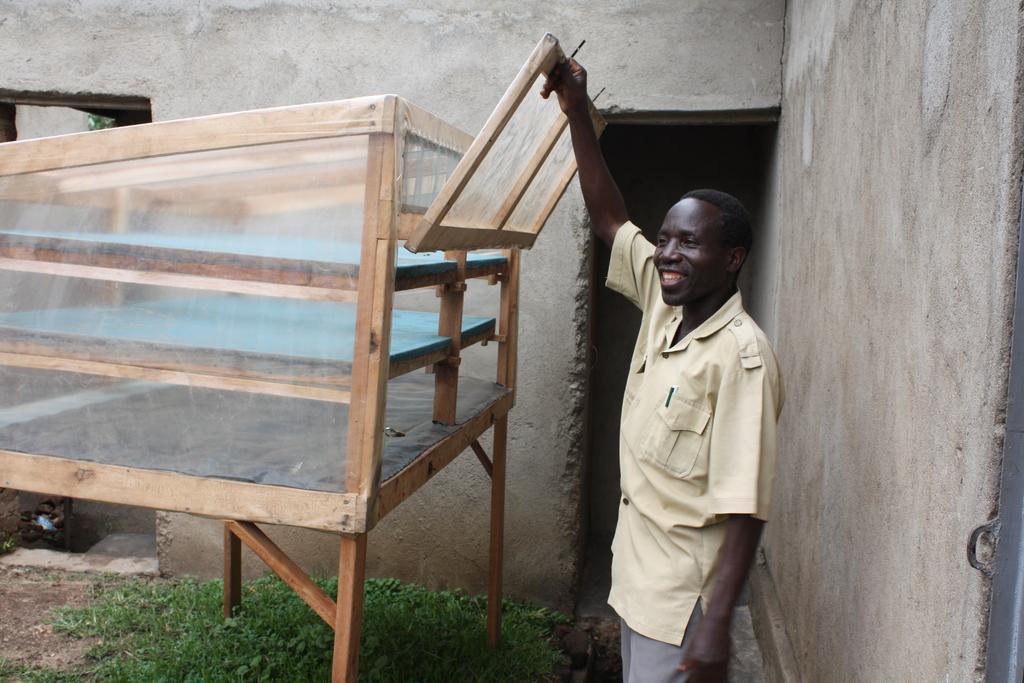Describe this image in one or two sentences. In this image there is a person truncated towards the bottom of the image, there is a wooden object truncated towards the left of the image, there is grass truncated towards the bottom of the image, there is the wall truncated towards the top of the image, there is the wall truncated towards the right of the image. 